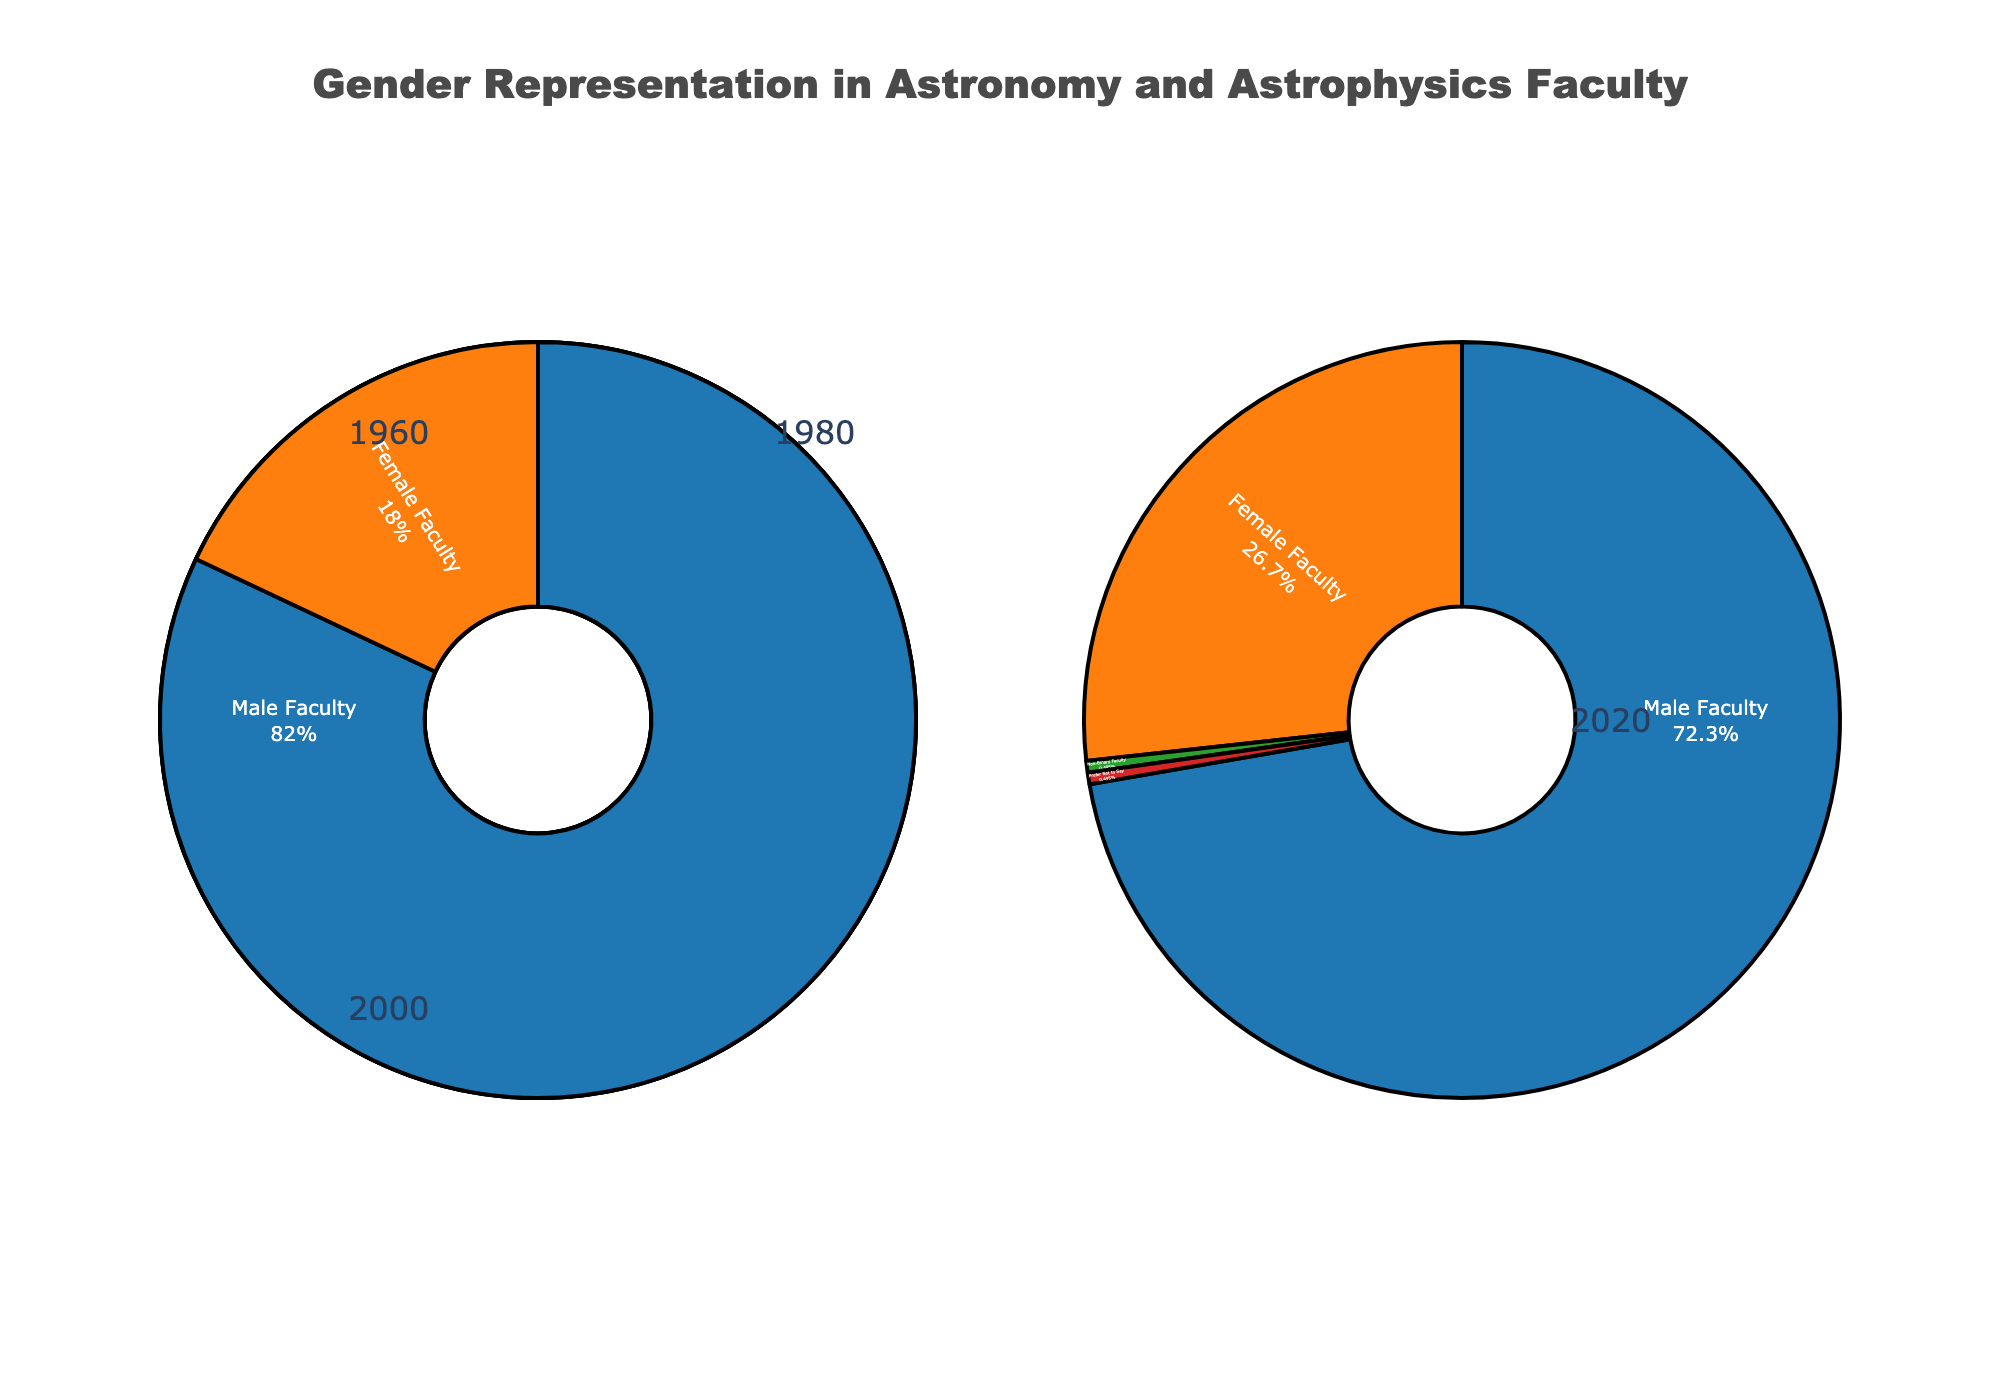What percentage of female faculty was there in 1960? Look at the pie chart for the year 1960, which shows the gender distribution of faculty. The portion labeled "Female Faculty" shows 4%.
Answer: 4% How did the percentage of male faculty change from 1960 to 2020? Compare the pie charts for 1960 and 2020. The male faculty percentage decreased from 96% in 1960 to 73% in 2020, a difference of 23%.
Answer: Decreased by 23% Was there a year when the representation of female faculty more than doubled from any previous year? Compare the percentages year by year. From 1960 (4%) to 1980 (11%) is almost a triple increase, but from 1980 (11%) to 2000 (18%) more than doubles.
Answer: Yes, from 1980 to 2000 What additional categories were added in 2020? Look at the pie chart for 2020. In addition to Male Faculty and Female Faculty, "Non-Binary Faculty" and "Prefer Not to Say" were included.
Answer: Non-Binary Faculty, Prefer Not to Say What is the difference in percentage between male and female faculty in 1980? Look at the pie chart for 1980. The difference is calculated by subtracting the percentage of Female Faculty (11%) from Male Faculty (89%).
Answer: 78% What year's pie chart has the smallest difference between male and female faculty? Compare the differences in percentages of male and female faculties for each year: 1960 (92%), 1980 (78%), 2000 (64%), 2020 (46%). The smallest difference is in 2020.
Answer: 2020 In 2020, what is the total percentage of categories other than male and female faculty combined? Add the percentages of Non-Binary Faculty (0.5%) and Prefer Not to Say (0.5%) from the 2020 pie chart.
Answer: 1% How did the percentage of female faculty change from 2000 to 2020? Compare the pie charts for 2000 and 2020. The female faculty percentage increased from 18% in 2000 to 27% in 2020. The difference is 27% - 18% = 9%.
Answer: Increased by 9% Between which consecutive years was the smallest increase in female faculty representation? Calculate the difference in female faculty percentages: 1960-1980 (7%), 1980-2000 (7%), 2000-2020 (9%). The smallest increase is either from 1960-1980 or 1980-2000.
Answer: 1960 to 1980 or 1980 to 2000 Which group saw the most significant decrease in percentage over the years? Comparing the Male Faculty percentages: 1960 (96%), 1980 (89%), 2000 (82%), 2020 (73%). The largest decrease is seen for Male Faculty.
Answer: Male Faculty 